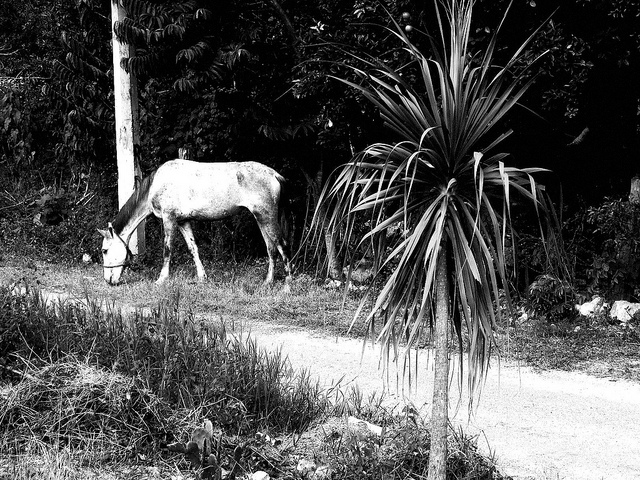What is the main subject of this black and white image? The main subject is a horse that appears to be grazing by the roadside. 